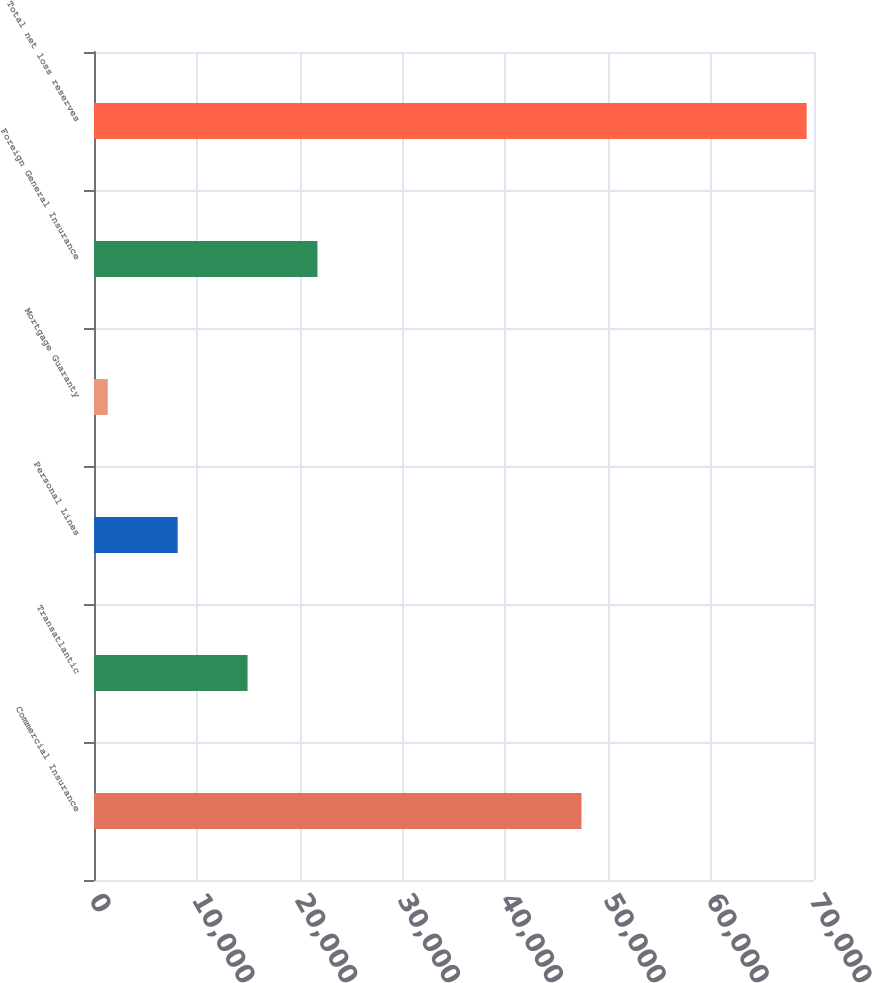Convert chart. <chart><loc_0><loc_0><loc_500><loc_500><bar_chart><fcel>Commercial Insurance<fcel>Transatlantic<fcel>Personal Lines<fcel>Mortgage Guaranty<fcel>Foreign General Insurance<fcel>Total net loss reserves<nl><fcel>47392<fcel>14928.8<fcel>8133.9<fcel>1339<fcel>21723.7<fcel>69288<nl></chart> 